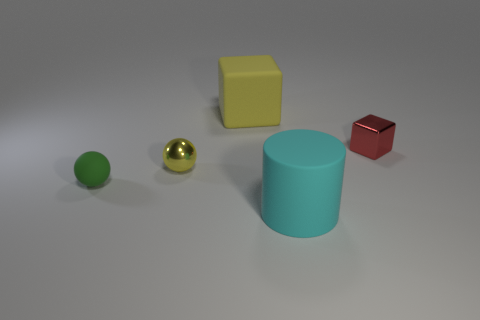Add 5 big objects. How many objects exist? 10 Subtract all cylinders. How many objects are left? 4 Add 4 big objects. How many big objects are left? 6 Add 2 yellow objects. How many yellow objects exist? 4 Subtract 0 blue spheres. How many objects are left? 5 Subtract all tiny cyan blocks. Subtract all yellow rubber blocks. How many objects are left? 4 